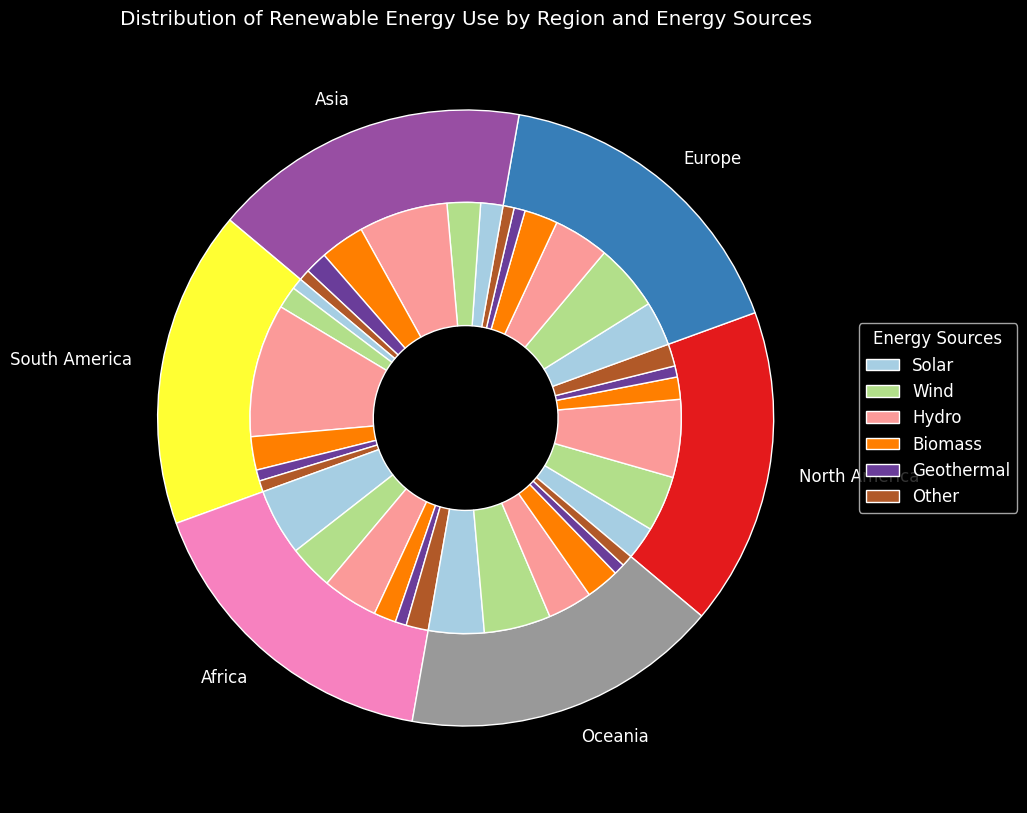Which region has the highest proportion of hydro energy use? By looking at the inner circle slices that represent hydro energy use, we can observe which region's slice is the largest in size. South America's slice for hydro energy use is the largest.
Answer: South America What is the combined proportion of biomass and solar energy use in Asia? We need to find the slices corresponding to biomass and solar for Asia, then add up the proportions of these slices in the inner circle. Biomass is 20% and solar is 10%. Combined, it's 20 + 10 = 30%.
Answer: 30% Which region has a larger proportion of wind energy use, Europe or North America? Compare the size of the slices for wind energy in Europe and North America in the inner circle. Europe's slice is bigger, which indicates a larger proportion.
Answer: Europe In which region does biomass energy usage constitute a greater proportion of its total energy usage compared to other regions? Examine each region's inner circle slices for the size of biomass energy use relative to other energy sources in that region. Asia has the largest proportion of biomass energy use compared to its other sources.
Answer: Asia What is the difference in the proportion of geothermal energy use between Africa and Oceania? Find the sizes of the inner slices for geothermal energy in Africa and Oceania and then calculate the difference. Both regions have a small size which represents almost equal proportions, specifically both are at 5%. So the difference is 0%.
Answer: 0% Which region contributes the least to the total renewable energy usage? Examine the sizes of the outer pie slices representing each region. South America's outer pie slice is the smallest.
Answer: South America How does the total usage of 'Other' energy sources in North America compare to that in Africa? Look at the inner circle slices corresponding to 'Other' for North America and Africa. Both slices should be estimated visually. North America and Africa each contribute around 10 to 'Other' energy sources, suggesting they are equal.
Answer: Equal If you combine the solar energy usage from North America and Africa, what proportion of the combined total usage do they represent? Calculate each region’s solar energy proportion individually, then sum them for the total combined solar usage. North America is 15 and Africa is 30; thus combined usage is 45. The total renewable usage from all regions combined is 500. Therefore, 45/500 = 9%.
Answer: 9% 